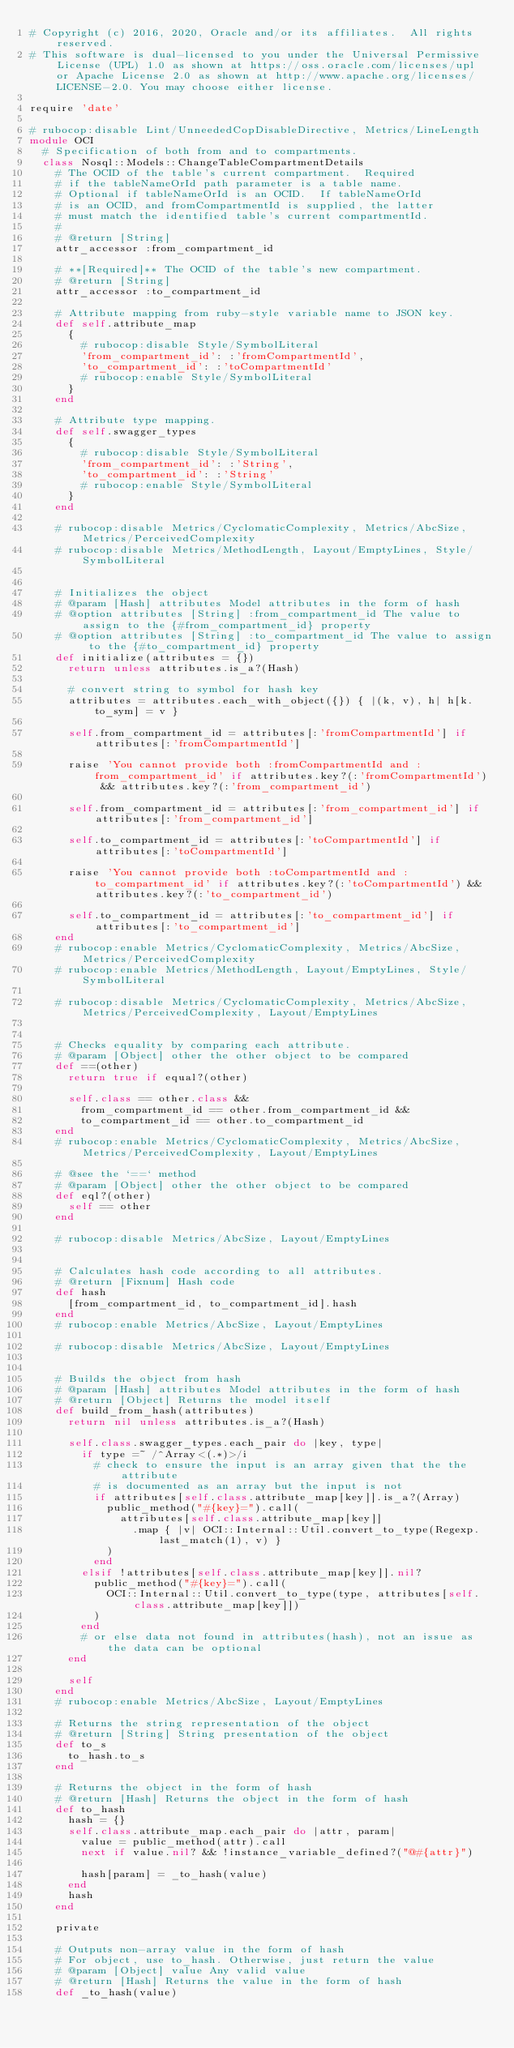<code> <loc_0><loc_0><loc_500><loc_500><_Ruby_># Copyright (c) 2016, 2020, Oracle and/or its affiliates.  All rights reserved.
# This software is dual-licensed to you under the Universal Permissive License (UPL) 1.0 as shown at https://oss.oracle.com/licenses/upl or Apache License 2.0 as shown at http://www.apache.org/licenses/LICENSE-2.0. You may choose either license.

require 'date'

# rubocop:disable Lint/UnneededCopDisableDirective, Metrics/LineLength
module OCI
  # Specification of both from and to compartments.
  class Nosql::Models::ChangeTableCompartmentDetails
    # The OCID of the table's current compartment.  Required
    # if the tableNameOrId path parameter is a table name.
    # Optional if tableNameOrId is an OCID.  If tableNameOrId
    # is an OCID, and fromCompartmentId is supplied, the latter
    # must match the identified table's current compartmentId.
    #
    # @return [String]
    attr_accessor :from_compartment_id

    # **[Required]** The OCID of the table's new compartment.
    # @return [String]
    attr_accessor :to_compartment_id

    # Attribute mapping from ruby-style variable name to JSON key.
    def self.attribute_map
      {
        # rubocop:disable Style/SymbolLiteral
        'from_compartment_id': :'fromCompartmentId',
        'to_compartment_id': :'toCompartmentId'
        # rubocop:enable Style/SymbolLiteral
      }
    end

    # Attribute type mapping.
    def self.swagger_types
      {
        # rubocop:disable Style/SymbolLiteral
        'from_compartment_id': :'String',
        'to_compartment_id': :'String'
        # rubocop:enable Style/SymbolLiteral
      }
    end

    # rubocop:disable Metrics/CyclomaticComplexity, Metrics/AbcSize, Metrics/PerceivedComplexity
    # rubocop:disable Metrics/MethodLength, Layout/EmptyLines, Style/SymbolLiteral


    # Initializes the object
    # @param [Hash] attributes Model attributes in the form of hash
    # @option attributes [String] :from_compartment_id The value to assign to the {#from_compartment_id} property
    # @option attributes [String] :to_compartment_id The value to assign to the {#to_compartment_id} property
    def initialize(attributes = {})
      return unless attributes.is_a?(Hash)

      # convert string to symbol for hash key
      attributes = attributes.each_with_object({}) { |(k, v), h| h[k.to_sym] = v }

      self.from_compartment_id = attributes[:'fromCompartmentId'] if attributes[:'fromCompartmentId']

      raise 'You cannot provide both :fromCompartmentId and :from_compartment_id' if attributes.key?(:'fromCompartmentId') && attributes.key?(:'from_compartment_id')

      self.from_compartment_id = attributes[:'from_compartment_id'] if attributes[:'from_compartment_id']

      self.to_compartment_id = attributes[:'toCompartmentId'] if attributes[:'toCompartmentId']

      raise 'You cannot provide both :toCompartmentId and :to_compartment_id' if attributes.key?(:'toCompartmentId') && attributes.key?(:'to_compartment_id')

      self.to_compartment_id = attributes[:'to_compartment_id'] if attributes[:'to_compartment_id']
    end
    # rubocop:enable Metrics/CyclomaticComplexity, Metrics/AbcSize, Metrics/PerceivedComplexity
    # rubocop:enable Metrics/MethodLength, Layout/EmptyLines, Style/SymbolLiteral

    # rubocop:disable Metrics/CyclomaticComplexity, Metrics/AbcSize, Metrics/PerceivedComplexity, Layout/EmptyLines


    # Checks equality by comparing each attribute.
    # @param [Object] other the other object to be compared
    def ==(other)
      return true if equal?(other)

      self.class == other.class &&
        from_compartment_id == other.from_compartment_id &&
        to_compartment_id == other.to_compartment_id
    end
    # rubocop:enable Metrics/CyclomaticComplexity, Metrics/AbcSize, Metrics/PerceivedComplexity, Layout/EmptyLines

    # @see the `==` method
    # @param [Object] other the other object to be compared
    def eql?(other)
      self == other
    end

    # rubocop:disable Metrics/AbcSize, Layout/EmptyLines


    # Calculates hash code according to all attributes.
    # @return [Fixnum] Hash code
    def hash
      [from_compartment_id, to_compartment_id].hash
    end
    # rubocop:enable Metrics/AbcSize, Layout/EmptyLines

    # rubocop:disable Metrics/AbcSize, Layout/EmptyLines


    # Builds the object from hash
    # @param [Hash] attributes Model attributes in the form of hash
    # @return [Object] Returns the model itself
    def build_from_hash(attributes)
      return nil unless attributes.is_a?(Hash)

      self.class.swagger_types.each_pair do |key, type|
        if type =~ /^Array<(.*)>/i
          # check to ensure the input is an array given that the the attribute
          # is documented as an array but the input is not
          if attributes[self.class.attribute_map[key]].is_a?(Array)
            public_method("#{key}=").call(
              attributes[self.class.attribute_map[key]]
                .map { |v| OCI::Internal::Util.convert_to_type(Regexp.last_match(1), v) }
            )
          end
        elsif !attributes[self.class.attribute_map[key]].nil?
          public_method("#{key}=").call(
            OCI::Internal::Util.convert_to_type(type, attributes[self.class.attribute_map[key]])
          )
        end
        # or else data not found in attributes(hash), not an issue as the data can be optional
      end

      self
    end
    # rubocop:enable Metrics/AbcSize, Layout/EmptyLines

    # Returns the string representation of the object
    # @return [String] String presentation of the object
    def to_s
      to_hash.to_s
    end

    # Returns the object in the form of hash
    # @return [Hash] Returns the object in the form of hash
    def to_hash
      hash = {}
      self.class.attribute_map.each_pair do |attr, param|
        value = public_method(attr).call
        next if value.nil? && !instance_variable_defined?("@#{attr}")

        hash[param] = _to_hash(value)
      end
      hash
    end

    private

    # Outputs non-array value in the form of hash
    # For object, use to_hash. Otherwise, just return the value
    # @param [Object] value Any valid value
    # @return [Hash] Returns the value in the form of hash
    def _to_hash(value)</code> 